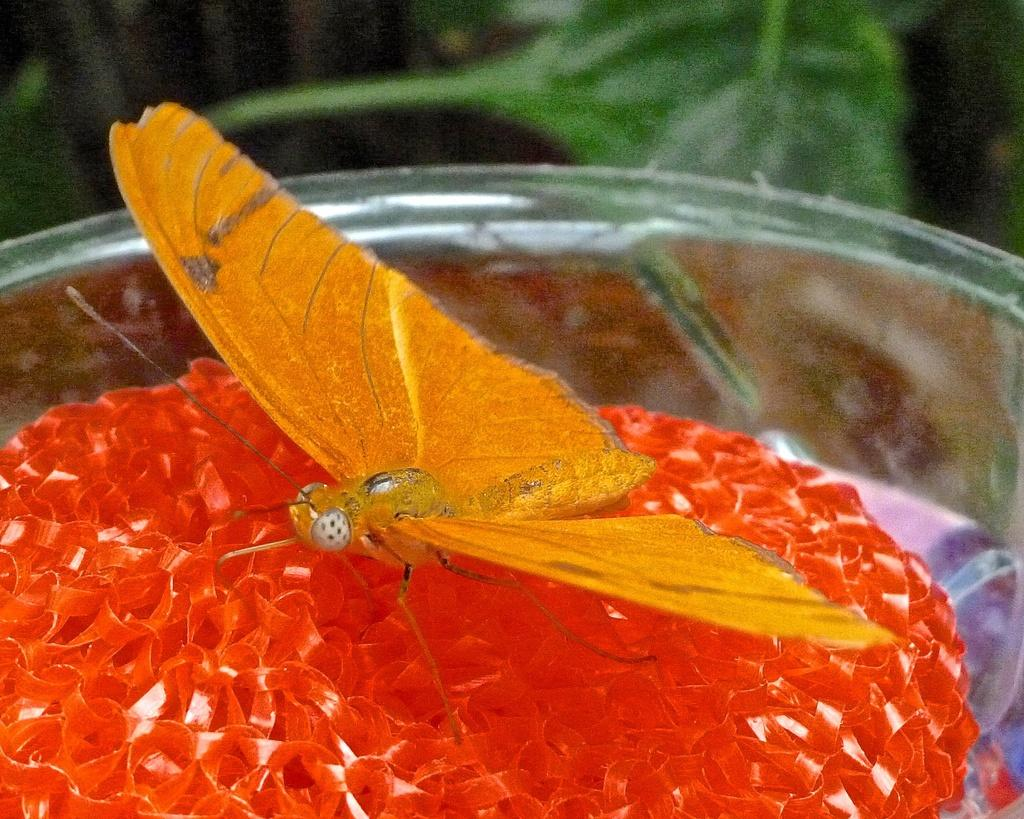What is the main subject of the image? There is a butterfly in the image. Where is the butterfly located? The butterfly is on an object. Can you describe the surface the object is placed on? The object is on a glass table. How would you describe the background of the image? The background of the image is blurry. What type of humor can be seen in the image? There is no humor present in the image; it features a butterfly on an object on a glass table with a blurry background. 